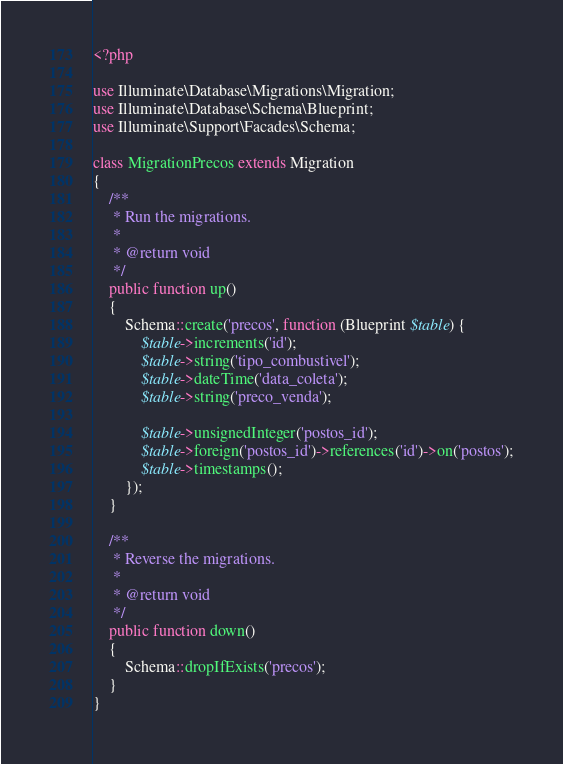Convert code to text. <code><loc_0><loc_0><loc_500><loc_500><_PHP_><?php

use Illuminate\Database\Migrations\Migration;
use Illuminate\Database\Schema\Blueprint;
use Illuminate\Support\Facades\Schema;

class MigrationPrecos extends Migration
{
    /**
     * Run the migrations.
     *
     * @return void
     */
    public function up()
    {
        Schema::create('precos', function (Blueprint $table) {
            $table->increments('id');
            $table->string('tipo_combustivel');
            $table->dateTime('data_coleta');
            $table->string('preco_venda');
            
            $table->unsignedInteger('postos_id');
            $table->foreign('postos_id')->references('id')->on('postos');
            $table->timestamps();
        });
    }

    /**
     * Reverse the migrations.
     *
     * @return void
     */
    public function down()
    {
        Schema::dropIfExists('precos');
    }
}</code> 